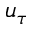Convert formula to latex. <formula><loc_0><loc_0><loc_500><loc_500>u _ { \tau }</formula> 